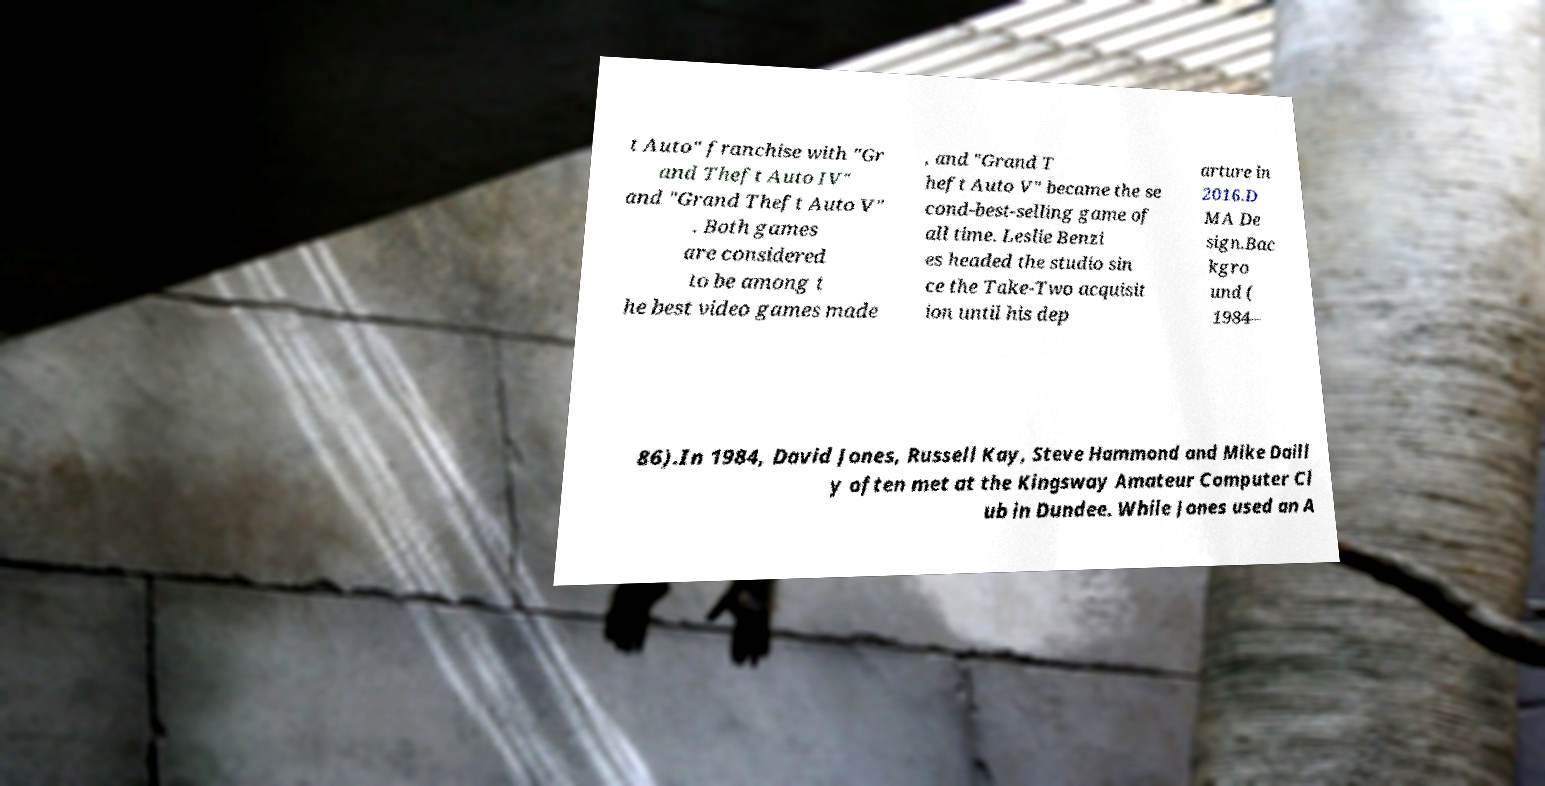Can you read and provide the text displayed in the image?This photo seems to have some interesting text. Can you extract and type it out for me? t Auto" franchise with "Gr and Theft Auto IV" and "Grand Theft Auto V" . Both games are considered to be among t he best video games made , and "Grand T heft Auto V" became the se cond-best-selling game of all time. Leslie Benzi es headed the studio sin ce the Take-Two acquisit ion until his dep arture in 2016.D MA De sign.Bac kgro und ( 1984– 86).In 1984, David Jones, Russell Kay, Steve Hammond and Mike Daill y often met at the Kingsway Amateur Computer Cl ub in Dundee. While Jones used an A 